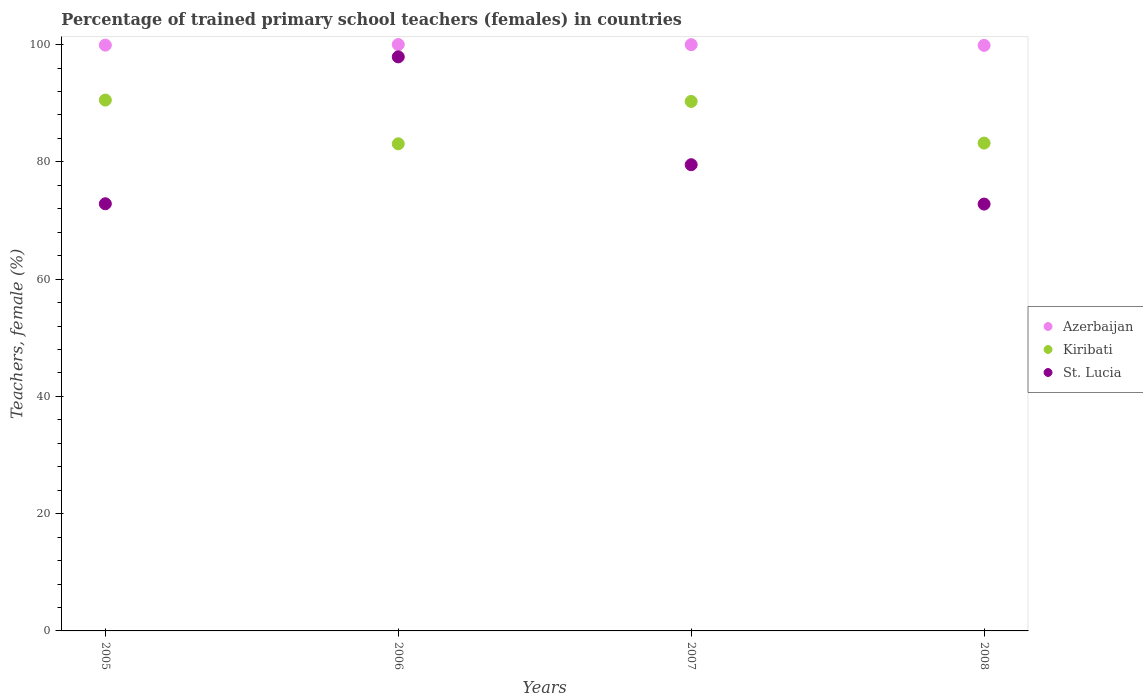How many different coloured dotlines are there?
Your response must be concise. 3. Is the number of dotlines equal to the number of legend labels?
Give a very brief answer. Yes. What is the percentage of trained primary school teachers (females) in Azerbaijan in 2008?
Make the answer very short. 99.86. Across all years, what is the maximum percentage of trained primary school teachers (females) in Kiribati?
Your answer should be compact. 90.53. Across all years, what is the minimum percentage of trained primary school teachers (females) in St. Lucia?
Make the answer very short. 72.79. In which year was the percentage of trained primary school teachers (females) in Azerbaijan minimum?
Keep it short and to the point. 2008. What is the total percentage of trained primary school teachers (females) in St. Lucia in the graph?
Provide a short and direct response. 323.05. What is the difference between the percentage of trained primary school teachers (females) in St. Lucia in 2007 and that in 2008?
Keep it short and to the point. 6.71. What is the difference between the percentage of trained primary school teachers (females) in St. Lucia in 2007 and the percentage of trained primary school teachers (females) in Kiribati in 2008?
Keep it short and to the point. -3.69. What is the average percentage of trained primary school teachers (females) in Kiribati per year?
Your response must be concise. 86.78. In the year 2005, what is the difference between the percentage of trained primary school teachers (females) in Azerbaijan and percentage of trained primary school teachers (females) in St. Lucia?
Make the answer very short. 27.05. In how many years, is the percentage of trained primary school teachers (females) in St. Lucia greater than 24 %?
Make the answer very short. 4. What is the ratio of the percentage of trained primary school teachers (females) in Azerbaijan in 2007 to that in 2008?
Offer a terse response. 1. Is the percentage of trained primary school teachers (females) in St. Lucia in 2005 less than that in 2007?
Provide a short and direct response. Yes. What is the difference between the highest and the second highest percentage of trained primary school teachers (females) in Kiribati?
Offer a terse response. 0.23. What is the difference between the highest and the lowest percentage of trained primary school teachers (females) in Kiribati?
Offer a terse response. 7.46. In how many years, is the percentage of trained primary school teachers (females) in Azerbaijan greater than the average percentage of trained primary school teachers (females) in Azerbaijan taken over all years?
Offer a terse response. 2. Is the sum of the percentage of trained primary school teachers (females) in St. Lucia in 2006 and 2007 greater than the maximum percentage of trained primary school teachers (females) in Kiribati across all years?
Ensure brevity in your answer.  Yes. Does the percentage of trained primary school teachers (females) in Kiribati monotonically increase over the years?
Offer a terse response. No. Is the percentage of trained primary school teachers (females) in Kiribati strictly greater than the percentage of trained primary school teachers (females) in Azerbaijan over the years?
Make the answer very short. No. How many dotlines are there?
Keep it short and to the point. 3. How many years are there in the graph?
Your response must be concise. 4. Does the graph contain any zero values?
Give a very brief answer. No. How many legend labels are there?
Offer a terse response. 3. How are the legend labels stacked?
Your answer should be compact. Vertical. What is the title of the graph?
Offer a terse response. Percentage of trained primary school teachers (females) in countries. What is the label or title of the Y-axis?
Your answer should be very brief. Teachers, female (%). What is the Teachers, female (%) of Azerbaijan in 2005?
Give a very brief answer. 99.9. What is the Teachers, female (%) of Kiribati in 2005?
Your answer should be compact. 90.53. What is the Teachers, female (%) in St. Lucia in 2005?
Provide a short and direct response. 72.85. What is the Teachers, female (%) of Azerbaijan in 2006?
Make the answer very short. 100. What is the Teachers, female (%) of Kiribati in 2006?
Your answer should be very brief. 83.08. What is the Teachers, female (%) of St. Lucia in 2006?
Make the answer very short. 97.9. What is the Teachers, female (%) of Azerbaijan in 2007?
Your answer should be compact. 99.98. What is the Teachers, female (%) of Kiribati in 2007?
Offer a very short reply. 90.3. What is the Teachers, female (%) in St. Lucia in 2007?
Ensure brevity in your answer.  79.51. What is the Teachers, female (%) in Azerbaijan in 2008?
Offer a very short reply. 99.86. What is the Teachers, female (%) of Kiribati in 2008?
Provide a short and direct response. 83.19. What is the Teachers, female (%) of St. Lucia in 2008?
Give a very brief answer. 72.79. Across all years, what is the maximum Teachers, female (%) of Azerbaijan?
Your response must be concise. 100. Across all years, what is the maximum Teachers, female (%) in Kiribati?
Ensure brevity in your answer.  90.53. Across all years, what is the maximum Teachers, female (%) in St. Lucia?
Your answer should be compact. 97.9. Across all years, what is the minimum Teachers, female (%) of Azerbaijan?
Provide a succinct answer. 99.86. Across all years, what is the minimum Teachers, female (%) of Kiribati?
Offer a very short reply. 83.08. Across all years, what is the minimum Teachers, female (%) in St. Lucia?
Your answer should be very brief. 72.79. What is the total Teachers, female (%) in Azerbaijan in the graph?
Keep it short and to the point. 399.75. What is the total Teachers, female (%) in Kiribati in the graph?
Keep it short and to the point. 347.1. What is the total Teachers, female (%) in St. Lucia in the graph?
Provide a short and direct response. 323.05. What is the difference between the Teachers, female (%) of Azerbaijan in 2005 and that in 2006?
Give a very brief answer. -0.1. What is the difference between the Teachers, female (%) in Kiribati in 2005 and that in 2006?
Your answer should be very brief. 7.46. What is the difference between the Teachers, female (%) of St. Lucia in 2005 and that in 2006?
Your answer should be compact. -25.05. What is the difference between the Teachers, female (%) of Azerbaijan in 2005 and that in 2007?
Your response must be concise. -0.08. What is the difference between the Teachers, female (%) in Kiribati in 2005 and that in 2007?
Keep it short and to the point. 0.23. What is the difference between the Teachers, female (%) in St. Lucia in 2005 and that in 2007?
Offer a terse response. -6.66. What is the difference between the Teachers, female (%) in Azerbaijan in 2005 and that in 2008?
Your answer should be very brief. 0.04. What is the difference between the Teachers, female (%) in Kiribati in 2005 and that in 2008?
Give a very brief answer. 7.34. What is the difference between the Teachers, female (%) in St. Lucia in 2005 and that in 2008?
Keep it short and to the point. 0.05. What is the difference between the Teachers, female (%) in Azerbaijan in 2006 and that in 2007?
Offer a terse response. 0.02. What is the difference between the Teachers, female (%) of Kiribati in 2006 and that in 2007?
Give a very brief answer. -7.22. What is the difference between the Teachers, female (%) of St. Lucia in 2006 and that in 2007?
Make the answer very short. 18.39. What is the difference between the Teachers, female (%) of Azerbaijan in 2006 and that in 2008?
Keep it short and to the point. 0.14. What is the difference between the Teachers, female (%) of Kiribati in 2006 and that in 2008?
Keep it short and to the point. -0.12. What is the difference between the Teachers, female (%) in St. Lucia in 2006 and that in 2008?
Provide a succinct answer. 25.11. What is the difference between the Teachers, female (%) of Azerbaijan in 2007 and that in 2008?
Provide a short and direct response. 0.12. What is the difference between the Teachers, female (%) in Kiribati in 2007 and that in 2008?
Your answer should be compact. 7.11. What is the difference between the Teachers, female (%) of St. Lucia in 2007 and that in 2008?
Your response must be concise. 6.71. What is the difference between the Teachers, female (%) of Azerbaijan in 2005 and the Teachers, female (%) of Kiribati in 2006?
Your answer should be compact. 16.83. What is the difference between the Teachers, female (%) in Azerbaijan in 2005 and the Teachers, female (%) in St. Lucia in 2006?
Offer a terse response. 2. What is the difference between the Teachers, female (%) in Kiribati in 2005 and the Teachers, female (%) in St. Lucia in 2006?
Provide a succinct answer. -7.37. What is the difference between the Teachers, female (%) in Azerbaijan in 2005 and the Teachers, female (%) in Kiribati in 2007?
Your answer should be compact. 9.6. What is the difference between the Teachers, female (%) of Azerbaijan in 2005 and the Teachers, female (%) of St. Lucia in 2007?
Your response must be concise. 20.39. What is the difference between the Teachers, female (%) of Kiribati in 2005 and the Teachers, female (%) of St. Lucia in 2007?
Provide a short and direct response. 11.02. What is the difference between the Teachers, female (%) in Azerbaijan in 2005 and the Teachers, female (%) in Kiribati in 2008?
Your answer should be very brief. 16.71. What is the difference between the Teachers, female (%) in Azerbaijan in 2005 and the Teachers, female (%) in St. Lucia in 2008?
Keep it short and to the point. 27.11. What is the difference between the Teachers, female (%) of Kiribati in 2005 and the Teachers, female (%) of St. Lucia in 2008?
Ensure brevity in your answer.  17.74. What is the difference between the Teachers, female (%) of Azerbaijan in 2006 and the Teachers, female (%) of Kiribati in 2007?
Ensure brevity in your answer.  9.7. What is the difference between the Teachers, female (%) of Azerbaijan in 2006 and the Teachers, female (%) of St. Lucia in 2007?
Provide a succinct answer. 20.49. What is the difference between the Teachers, female (%) of Kiribati in 2006 and the Teachers, female (%) of St. Lucia in 2007?
Provide a short and direct response. 3.57. What is the difference between the Teachers, female (%) in Azerbaijan in 2006 and the Teachers, female (%) in Kiribati in 2008?
Provide a short and direct response. 16.81. What is the difference between the Teachers, female (%) of Azerbaijan in 2006 and the Teachers, female (%) of St. Lucia in 2008?
Your response must be concise. 27.21. What is the difference between the Teachers, female (%) in Kiribati in 2006 and the Teachers, female (%) in St. Lucia in 2008?
Your answer should be compact. 10.28. What is the difference between the Teachers, female (%) in Azerbaijan in 2007 and the Teachers, female (%) in Kiribati in 2008?
Make the answer very short. 16.79. What is the difference between the Teachers, female (%) in Azerbaijan in 2007 and the Teachers, female (%) in St. Lucia in 2008?
Offer a terse response. 27.19. What is the difference between the Teachers, female (%) in Kiribati in 2007 and the Teachers, female (%) in St. Lucia in 2008?
Keep it short and to the point. 17.5. What is the average Teachers, female (%) of Azerbaijan per year?
Offer a very short reply. 99.94. What is the average Teachers, female (%) in Kiribati per year?
Provide a short and direct response. 86.78. What is the average Teachers, female (%) of St. Lucia per year?
Give a very brief answer. 80.76. In the year 2005, what is the difference between the Teachers, female (%) in Azerbaijan and Teachers, female (%) in Kiribati?
Offer a terse response. 9.37. In the year 2005, what is the difference between the Teachers, female (%) of Azerbaijan and Teachers, female (%) of St. Lucia?
Offer a terse response. 27.05. In the year 2005, what is the difference between the Teachers, female (%) of Kiribati and Teachers, female (%) of St. Lucia?
Your answer should be very brief. 17.68. In the year 2006, what is the difference between the Teachers, female (%) of Azerbaijan and Teachers, female (%) of Kiribati?
Provide a succinct answer. 16.92. In the year 2006, what is the difference between the Teachers, female (%) of Azerbaijan and Teachers, female (%) of St. Lucia?
Keep it short and to the point. 2.1. In the year 2006, what is the difference between the Teachers, female (%) in Kiribati and Teachers, female (%) in St. Lucia?
Your answer should be very brief. -14.83. In the year 2007, what is the difference between the Teachers, female (%) of Azerbaijan and Teachers, female (%) of Kiribati?
Ensure brevity in your answer.  9.68. In the year 2007, what is the difference between the Teachers, female (%) in Azerbaijan and Teachers, female (%) in St. Lucia?
Offer a terse response. 20.47. In the year 2007, what is the difference between the Teachers, female (%) in Kiribati and Teachers, female (%) in St. Lucia?
Provide a succinct answer. 10.79. In the year 2008, what is the difference between the Teachers, female (%) of Azerbaijan and Teachers, female (%) of Kiribati?
Keep it short and to the point. 16.67. In the year 2008, what is the difference between the Teachers, female (%) of Azerbaijan and Teachers, female (%) of St. Lucia?
Give a very brief answer. 27.07. In the year 2008, what is the difference between the Teachers, female (%) in Kiribati and Teachers, female (%) in St. Lucia?
Keep it short and to the point. 10.4. What is the ratio of the Teachers, female (%) in Kiribati in 2005 to that in 2006?
Your answer should be very brief. 1.09. What is the ratio of the Teachers, female (%) of St. Lucia in 2005 to that in 2006?
Keep it short and to the point. 0.74. What is the ratio of the Teachers, female (%) in Kiribati in 2005 to that in 2007?
Ensure brevity in your answer.  1. What is the ratio of the Teachers, female (%) in St. Lucia in 2005 to that in 2007?
Give a very brief answer. 0.92. What is the ratio of the Teachers, female (%) in Kiribati in 2005 to that in 2008?
Provide a short and direct response. 1.09. What is the ratio of the Teachers, female (%) of St. Lucia in 2005 to that in 2008?
Provide a succinct answer. 1. What is the ratio of the Teachers, female (%) of Azerbaijan in 2006 to that in 2007?
Offer a very short reply. 1. What is the ratio of the Teachers, female (%) of St. Lucia in 2006 to that in 2007?
Your answer should be very brief. 1.23. What is the ratio of the Teachers, female (%) of St. Lucia in 2006 to that in 2008?
Keep it short and to the point. 1.34. What is the ratio of the Teachers, female (%) in Kiribati in 2007 to that in 2008?
Keep it short and to the point. 1.09. What is the ratio of the Teachers, female (%) of St. Lucia in 2007 to that in 2008?
Keep it short and to the point. 1.09. What is the difference between the highest and the second highest Teachers, female (%) in Azerbaijan?
Your answer should be compact. 0.02. What is the difference between the highest and the second highest Teachers, female (%) of Kiribati?
Make the answer very short. 0.23. What is the difference between the highest and the second highest Teachers, female (%) of St. Lucia?
Your response must be concise. 18.39. What is the difference between the highest and the lowest Teachers, female (%) of Azerbaijan?
Your answer should be compact. 0.14. What is the difference between the highest and the lowest Teachers, female (%) in Kiribati?
Make the answer very short. 7.46. What is the difference between the highest and the lowest Teachers, female (%) of St. Lucia?
Provide a succinct answer. 25.11. 